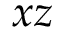Convert formula to latex. <formula><loc_0><loc_0><loc_500><loc_500>x z</formula> 